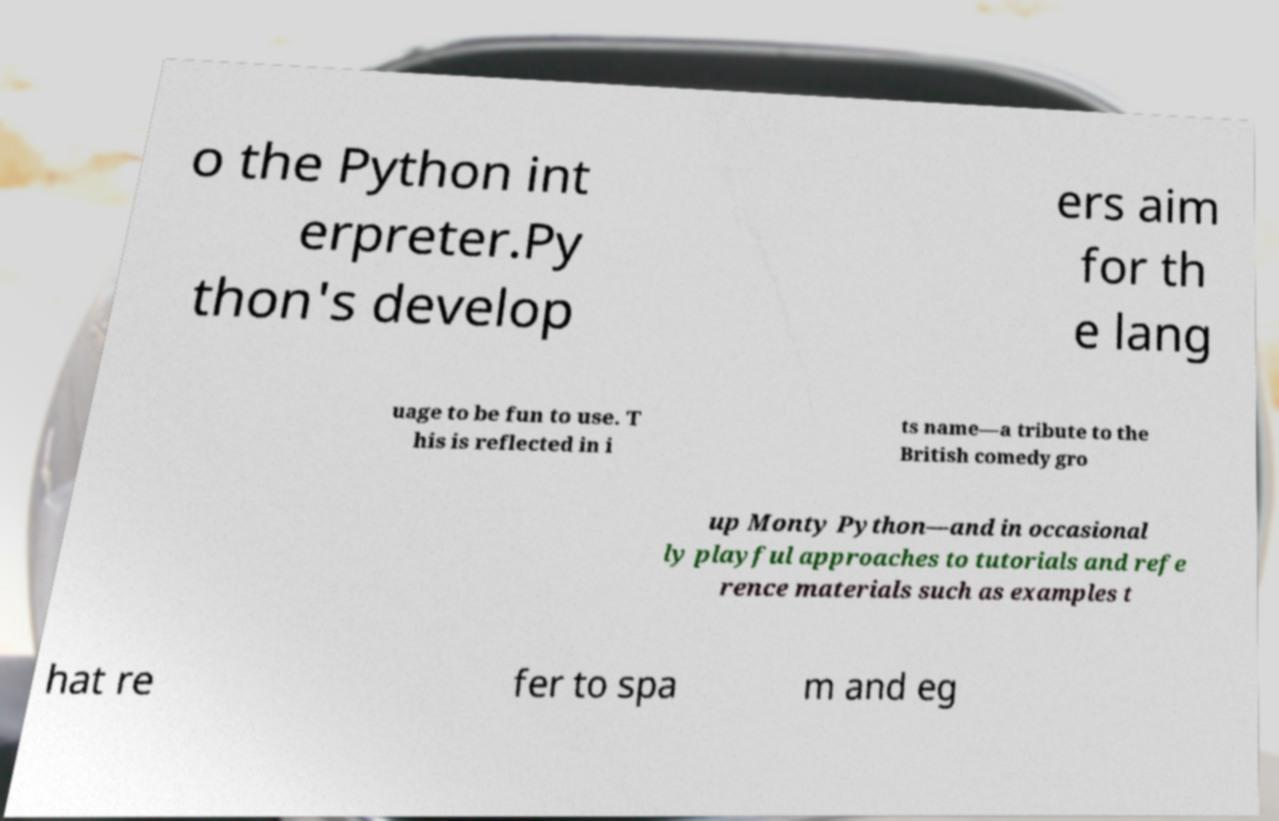Can you accurately transcribe the text from the provided image for me? o the Python int erpreter.Py thon's develop ers aim for th e lang uage to be fun to use. T his is reflected in i ts name—a tribute to the British comedy gro up Monty Python—and in occasional ly playful approaches to tutorials and refe rence materials such as examples t hat re fer to spa m and eg 